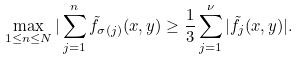Convert formula to latex. <formula><loc_0><loc_0><loc_500><loc_500>\max _ { 1 \leq n \leq N } | \sum _ { j = 1 } ^ { n } \tilde { f } _ { \sigma ( j ) } ( x , y ) \geq \frac { 1 } { 3 } \sum _ { j = 1 } ^ { \nu } | \tilde { f } _ { j } ( x , y ) | .</formula> 